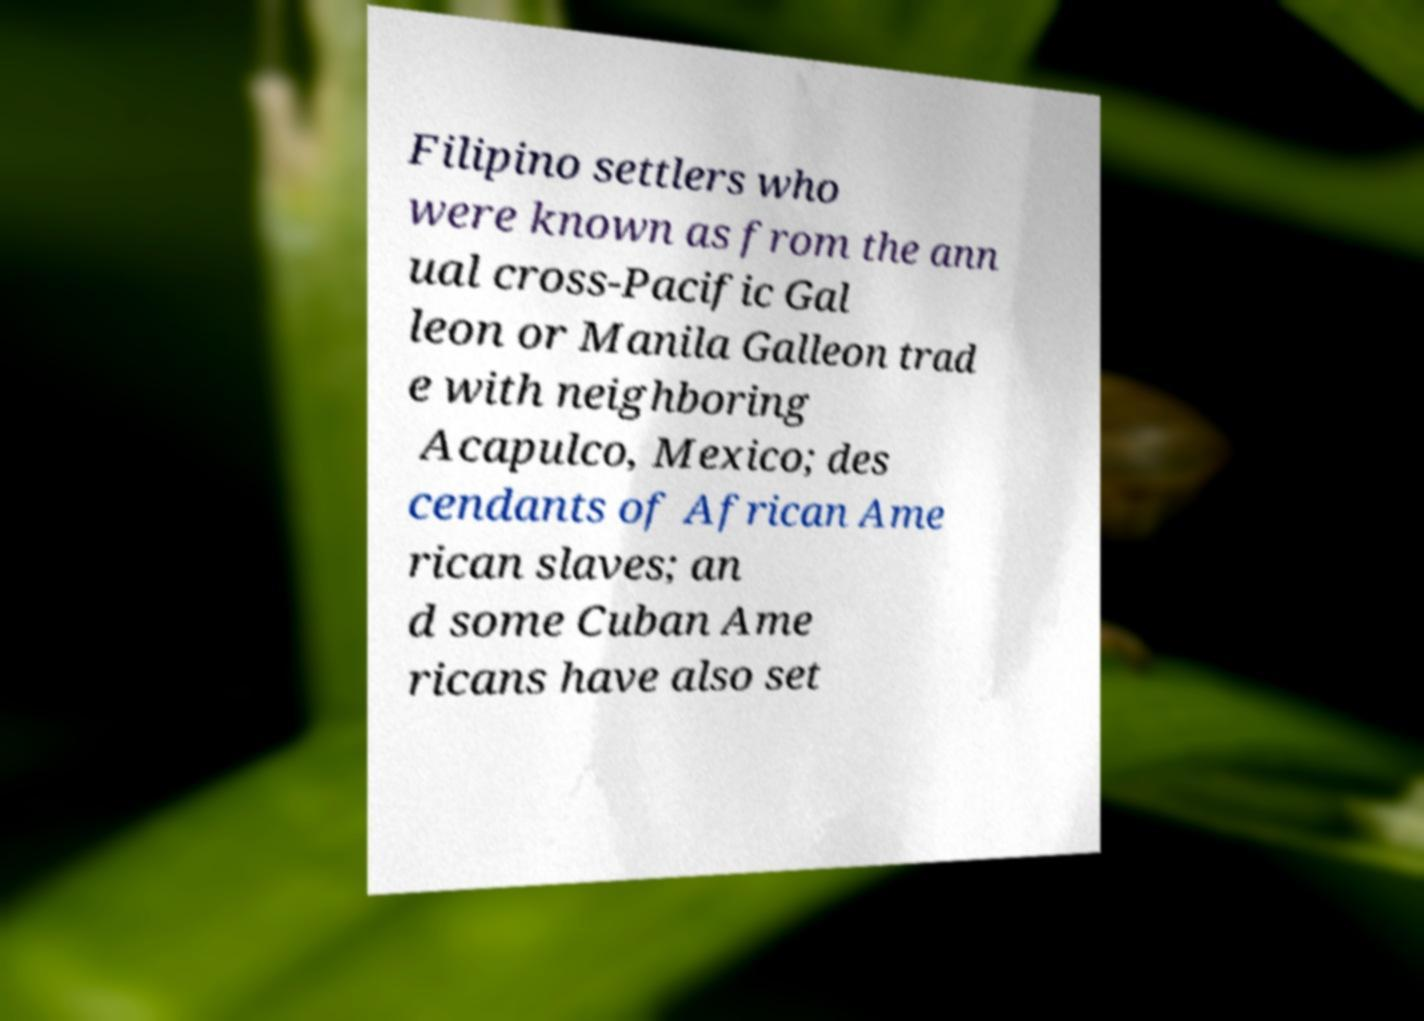Please identify and transcribe the text found in this image. Filipino settlers who were known as from the ann ual cross-Pacific Gal leon or Manila Galleon trad e with neighboring Acapulco, Mexico; des cendants of African Ame rican slaves; an d some Cuban Ame ricans have also set 